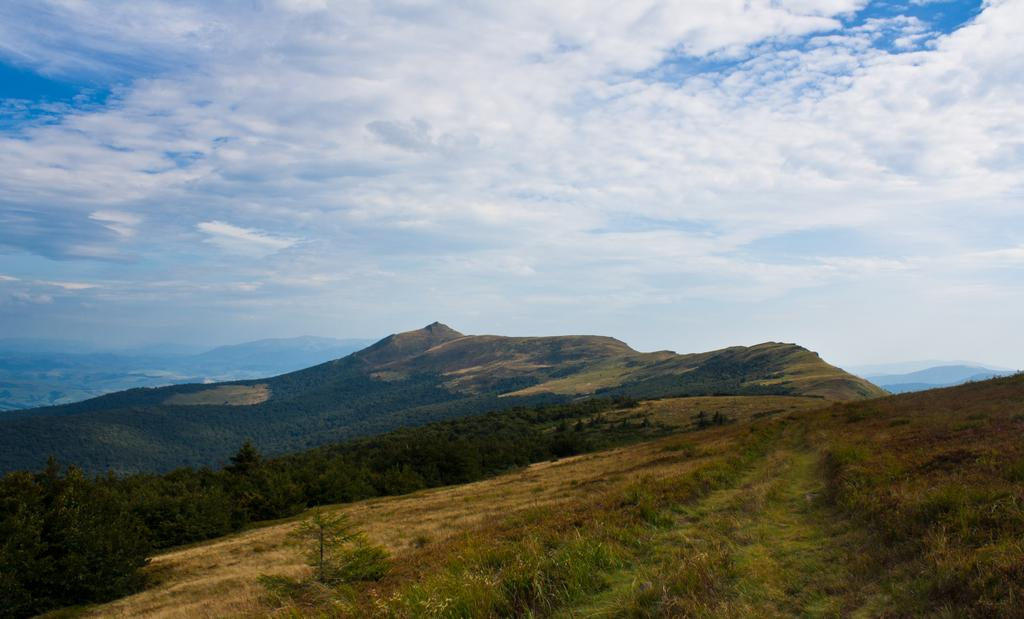What type of natural formation is visible in the image? There is a mountain in the image. What type of vegetation can be seen in the image? There are trees, plants, and grass visible in the image. What is visible at the top of the image? The sky is visible at the top of the image. What can be observed in the sky? Clouds are present in the sky. Where is the rabbit hiding in the image? There is no rabbit present in the image. What type of lumber is being used to construct the mountain in the image? The mountain is a natural formation and does not involve the use of lumber. 